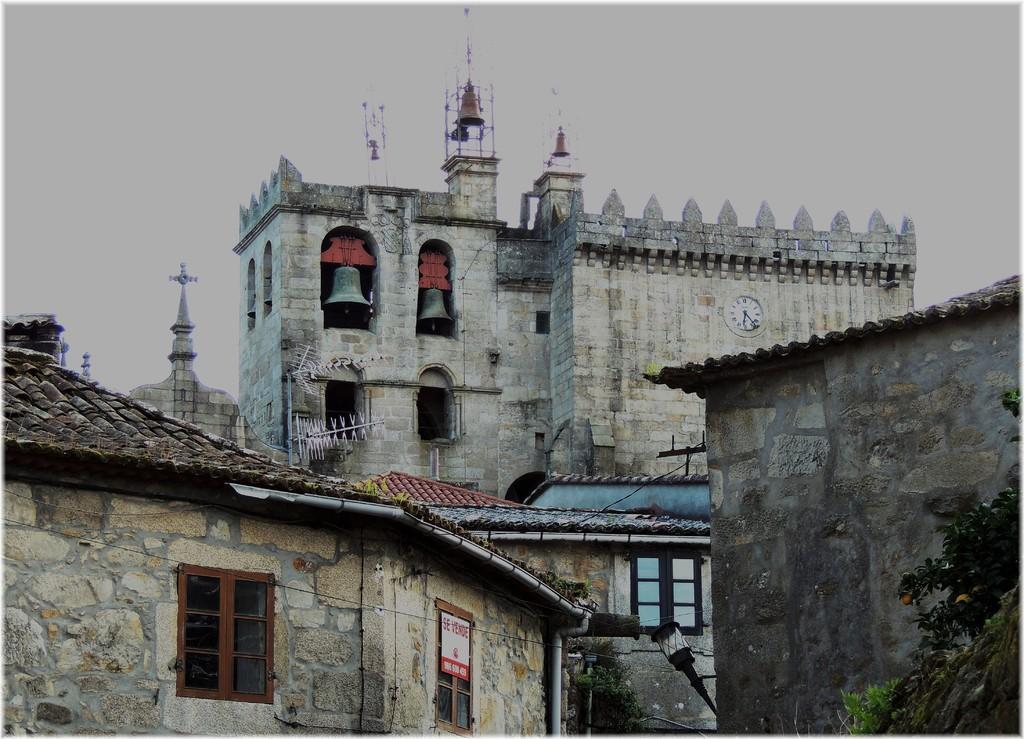Describe this image in one or two sentences. In this picture there is a white color granite church with two hanging bells. On the top we can see the cross marks. In the front bottom side there is a small houses with roofing tiles and brown windows. 